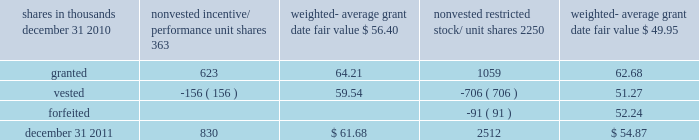There were no options granted in excess of market value in 2011 , 2010 or 2009 .
Shares of common stock available during the next year for the granting of options and other awards under the incentive plans were 33775543 at december 31 , 2011 .
Total shares of pnc common stock authorized for future issuance under equity compensation plans totaled 35304422 shares at december 31 , 2011 , which includes shares available for issuance under the incentive plans and the employee stock purchase plan ( espp ) as described below .
During 2011 , we issued 731336 shares from treasury stock in connection with stock option exercise activity .
As with past exercise activity , we currently intend to utilize primarily treasury stock for any future stock option exercises .
Awards granted to non-employee directors in 2011 , 2010 and 2009 include 27090 , 29040 , and 39552 deferred stock units , respectively , awarded under the outside directors deferred stock unit plan .
A deferred stock unit is a phantom share of our common stock , which requires liability accounting treatment until such awards are paid to the participants as cash .
As there are no vesting or service requirements on these awards , total compensation expense is recognized in full on awarded deferred stock units on the date of grant .
Incentive/performance unit share awards and restricted stock/unit awards the fair value of nonvested incentive/performance unit share awards and restricted stock/unit awards is initially determined based on prices not less than the market value of our common stock price on the date of grant .
The value of certain incentive/ performance unit share awards is subsequently remeasured based on the achievement of one or more financial and other performance goals generally over a three-year period .
The personnel and compensation committee of the board of directors approves the final award payout with respect to incentive/performance unit share awards .
Restricted stock/unit awards have various vesting periods generally ranging from 36 months to 60 months .
Beginning in 2011 , we incorporated two changes to certain awards under our existing long-term incentive compensation programs .
First , for certain grants of incentive performance units , the future payout amount will be subject to a negative annual adjustment if pnc fails to meet certain risk-related performance metrics .
This adjustment is in addition to the existing financial performance metrics relative to our peers .
These grants have a three-year performance period and are payable in either stock or a combination of stock and cash .
Second , performance-based restricted share units ( performance rsus ) were granted in 2011 to certain of our executives in lieu of stock options .
These performance rsus ( which are payable solely in stock ) have a service condition , an internal risk-related performance condition , and an external market condition .
Satisfaction of the performance condition is based on four independent one-year performance periods .
The weighted-average grant-date fair value of incentive/ performance unit share awards and restricted stock/unit awards granted in 2011 , 2010 and 2009 was $ 63.25 , $ 54.59 and $ 41.16 per share , respectively .
We recognize compensation expense for such awards ratably over the corresponding vesting and/or performance periods for each type of program .
Nonvested incentive/performance unit share awards and restricted stock/unit awards 2013 rollforward shares in thousands nonvested incentive/ performance unit shares weighted- average date fair nonvested restricted stock/ shares weighted- average date fair .
In the chart above , the unit shares and related weighted- average grant-date fair value of the incentive/performance awards exclude the effect of dividends on the underlying shares , as those dividends will be paid in cash .
At december 31 , 2011 , there was $ 61 million of unrecognized deferred compensation expense related to nonvested share- based compensation arrangements granted under the incentive plans .
This cost is expected to be recognized as expense over a period of no longer than five years .
The total fair value of incentive/performance unit share and restricted stock/unit awards vested during 2011 , 2010 and 2009 was approximately $ 52 million , $ 39 million and $ 47 million , respectively .
Liability awards we grant annually cash-payable restricted share units to certain executives .
The grants were made primarily as part of an annual bonus incentive deferral plan .
While there are time- based and service-related vesting criteria , there are no market or performance criteria associated with these awards .
Compensation expense recognized related to these awards was recorded in prior periods as part of annual cash bonus criteria .
As of december 31 , 2011 , there were 753203 of these cash- payable restricted share units outstanding .
174 the pnc financial services group , inc .
2013 form 10-k .
In 2011 what was the change nonvested incentive/ performance unit shares? 
Computations: (830 - 363)
Answer: 467.0. 